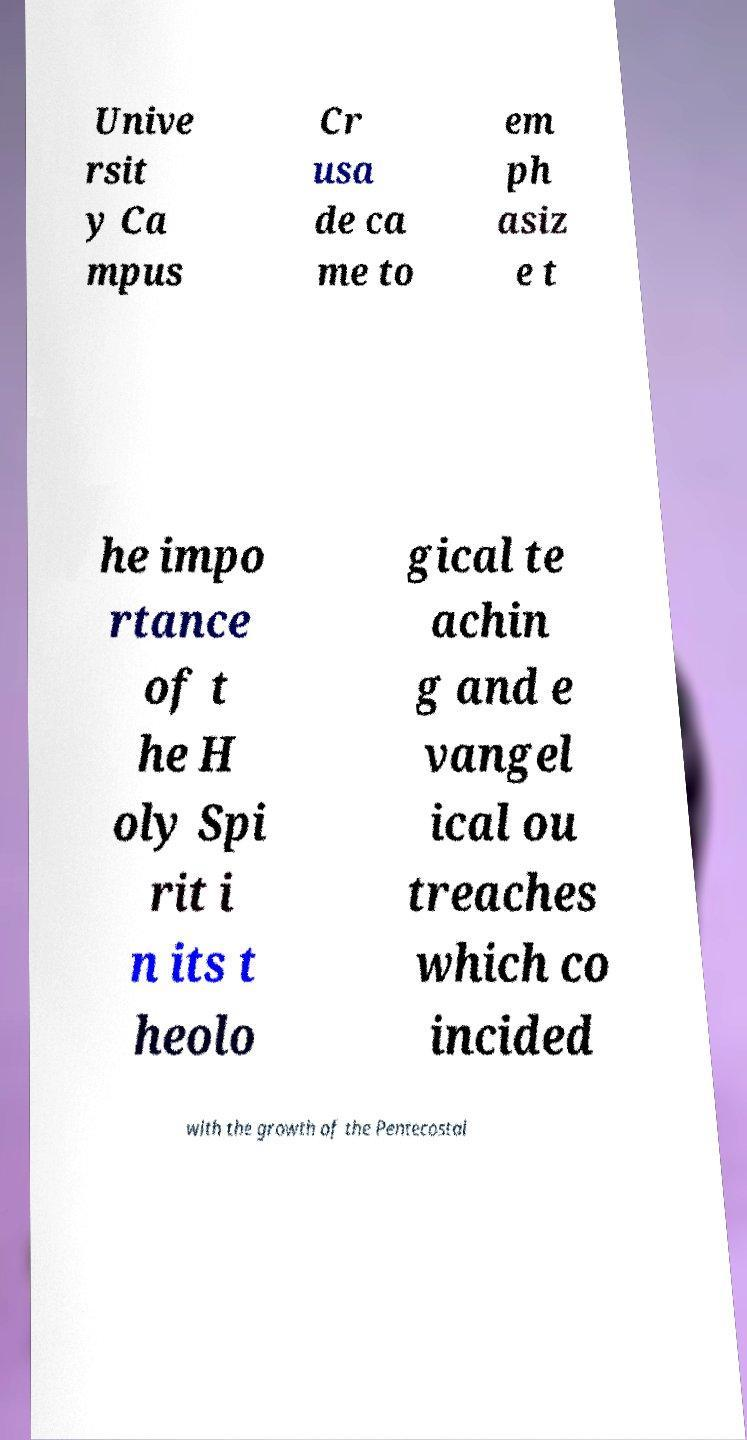Could you assist in decoding the text presented in this image and type it out clearly? Unive rsit y Ca mpus Cr usa de ca me to em ph asiz e t he impo rtance of t he H oly Spi rit i n its t heolo gical te achin g and e vangel ical ou treaches which co incided with the growth of the Pentecostal 